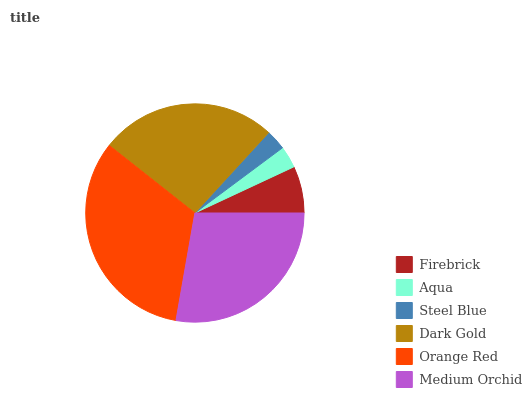Is Steel Blue the minimum?
Answer yes or no. Yes. Is Orange Red the maximum?
Answer yes or no. Yes. Is Aqua the minimum?
Answer yes or no. No. Is Aqua the maximum?
Answer yes or no. No. Is Firebrick greater than Aqua?
Answer yes or no. Yes. Is Aqua less than Firebrick?
Answer yes or no. Yes. Is Aqua greater than Firebrick?
Answer yes or no. No. Is Firebrick less than Aqua?
Answer yes or no. No. Is Dark Gold the high median?
Answer yes or no. Yes. Is Firebrick the low median?
Answer yes or no. Yes. Is Medium Orchid the high median?
Answer yes or no. No. Is Orange Red the low median?
Answer yes or no. No. 